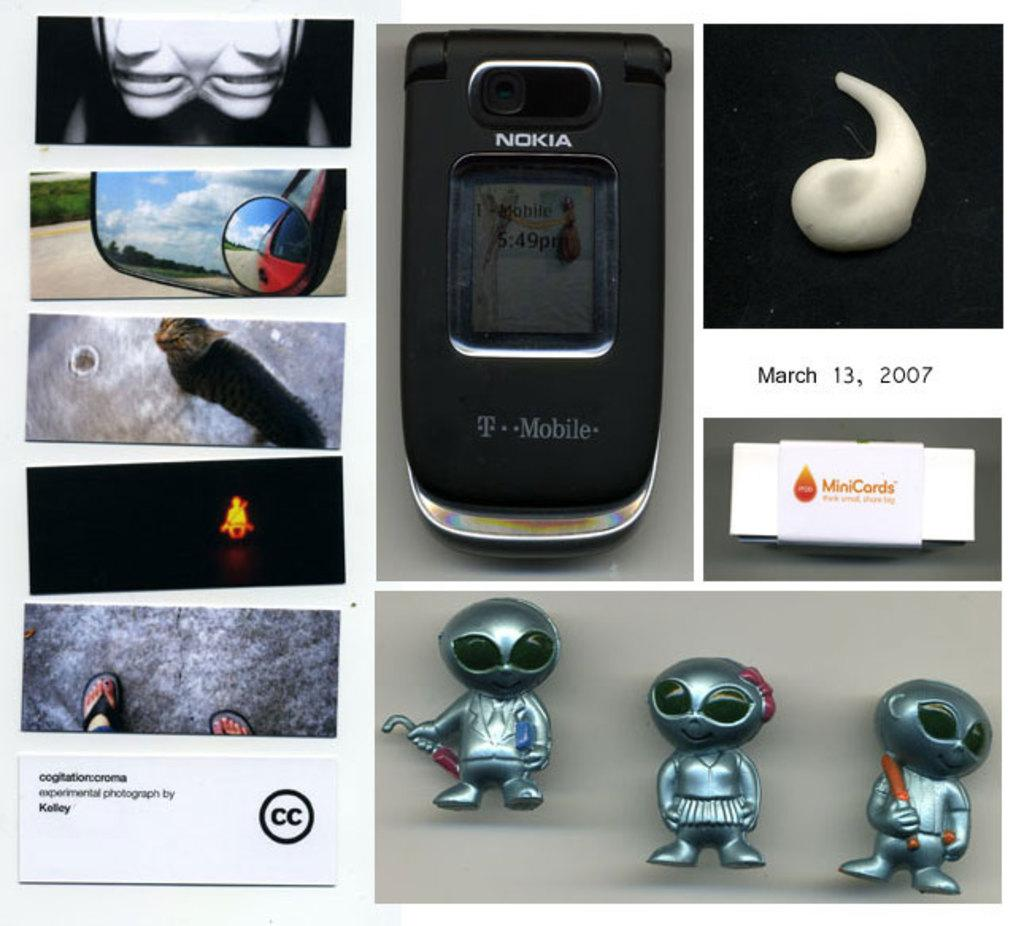Provide a one-sentence caption for the provided image. Various images, including a Nokia cellphone, little alien figurines and photos of cropped objects. 